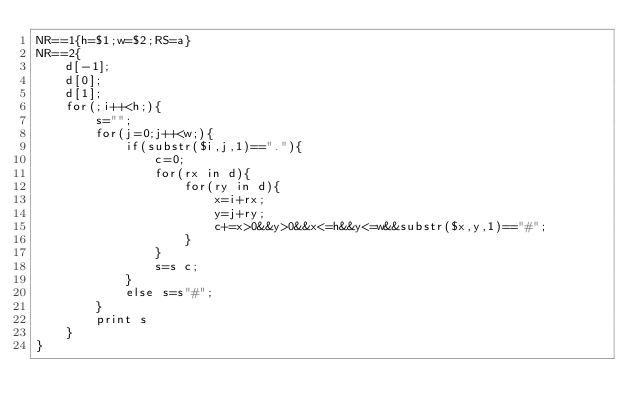Convert code to text. <code><loc_0><loc_0><loc_500><loc_500><_Awk_>NR==1{h=$1;w=$2;RS=a}
NR==2{
	d[-1];
	d[0];
	d[1];
	for(;i++<h;){
		s="";
		for(j=0;j++<w;){
			if(substr($i,j,1)=="."){
				c=0;
				for(rx in d){
					for(ry in d){
						x=i+rx;
						y=j+ry;
						c+=x>0&&y>0&&x<=h&&y<=w&&substr($x,y,1)=="#";
					}
				}
				s=s c;
			}
			else s=s"#";
		}
		print s
	}
}</code> 